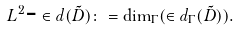Convert formula to latex. <formula><loc_0><loc_0><loc_500><loc_500>L ^ { 2 } \text {-} \in d ( \tilde { D } ) \colon = \dim _ { \Gamma } ( \in d _ { \Gamma } ( \tilde { D } ) ) .</formula> 